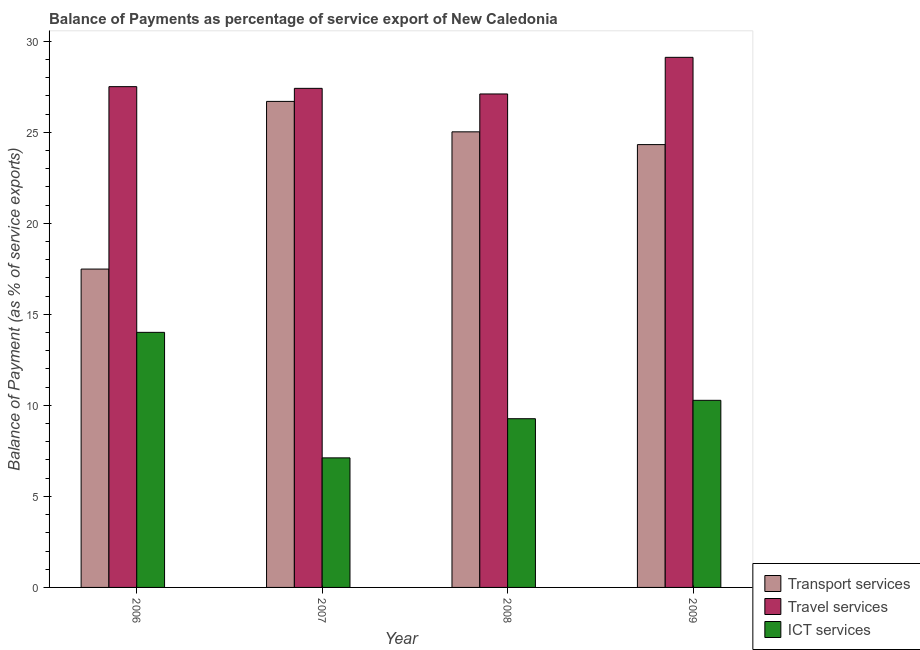What is the balance of payment of transport services in 2007?
Your answer should be compact. 26.7. Across all years, what is the maximum balance of payment of travel services?
Ensure brevity in your answer.  29.12. Across all years, what is the minimum balance of payment of ict services?
Provide a short and direct response. 7.12. In which year was the balance of payment of travel services maximum?
Keep it short and to the point. 2009. In which year was the balance of payment of travel services minimum?
Your answer should be very brief. 2008. What is the total balance of payment of transport services in the graph?
Keep it short and to the point. 93.54. What is the difference between the balance of payment of travel services in 2008 and that in 2009?
Provide a short and direct response. -2.01. What is the difference between the balance of payment of travel services in 2007 and the balance of payment of transport services in 2006?
Offer a terse response. -0.09. What is the average balance of payment of ict services per year?
Offer a very short reply. 10.17. What is the ratio of the balance of payment of ict services in 2006 to that in 2008?
Provide a short and direct response. 1.51. Is the difference between the balance of payment of travel services in 2006 and 2007 greater than the difference between the balance of payment of transport services in 2006 and 2007?
Your answer should be very brief. No. What is the difference between the highest and the second highest balance of payment of travel services?
Offer a very short reply. 1.61. What is the difference between the highest and the lowest balance of payment of travel services?
Give a very brief answer. 2.01. In how many years, is the balance of payment of ict services greater than the average balance of payment of ict services taken over all years?
Offer a very short reply. 2. What does the 3rd bar from the left in 2009 represents?
Your answer should be very brief. ICT services. What does the 3rd bar from the right in 2008 represents?
Provide a succinct answer. Transport services. Is it the case that in every year, the sum of the balance of payment of transport services and balance of payment of travel services is greater than the balance of payment of ict services?
Make the answer very short. Yes. How many bars are there?
Provide a short and direct response. 12. Are all the bars in the graph horizontal?
Offer a very short reply. No. How many years are there in the graph?
Keep it short and to the point. 4. What is the difference between two consecutive major ticks on the Y-axis?
Your response must be concise. 5. Are the values on the major ticks of Y-axis written in scientific E-notation?
Provide a short and direct response. No. Does the graph contain grids?
Give a very brief answer. No. Where does the legend appear in the graph?
Provide a succinct answer. Bottom right. What is the title of the graph?
Offer a terse response. Balance of Payments as percentage of service export of New Caledonia. Does "Coal" appear as one of the legend labels in the graph?
Your answer should be very brief. No. What is the label or title of the Y-axis?
Provide a short and direct response. Balance of Payment (as % of service exports). What is the Balance of Payment (as % of service exports) of Transport services in 2006?
Your answer should be very brief. 17.49. What is the Balance of Payment (as % of service exports) in Travel services in 2006?
Your answer should be very brief. 27.51. What is the Balance of Payment (as % of service exports) of ICT services in 2006?
Ensure brevity in your answer.  14.01. What is the Balance of Payment (as % of service exports) in Transport services in 2007?
Keep it short and to the point. 26.7. What is the Balance of Payment (as % of service exports) in Travel services in 2007?
Give a very brief answer. 27.42. What is the Balance of Payment (as % of service exports) in ICT services in 2007?
Your answer should be very brief. 7.12. What is the Balance of Payment (as % of service exports) in Transport services in 2008?
Your answer should be very brief. 25.03. What is the Balance of Payment (as % of service exports) in Travel services in 2008?
Offer a very short reply. 27.11. What is the Balance of Payment (as % of service exports) of ICT services in 2008?
Your answer should be compact. 9.27. What is the Balance of Payment (as % of service exports) in Transport services in 2009?
Ensure brevity in your answer.  24.33. What is the Balance of Payment (as % of service exports) in Travel services in 2009?
Provide a succinct answer. 29.12. What is the Balance of Payment (as % of service exports) of ICT services in 2009?
Give a very brief answer. 10.28. Across all years, what is the maximum Balance of Payment (as % of service exports) of Transport services?
Ensure brevity in your answer.  26.7. Across all years, what is the maximum Balance of Payment (as % of service exports) in Travel services?
Offer a terse response. 29.12. Across all years, what is the maximum Balance of Payment (as % of service exports) of ICT services?
Give a very brief answer. 14.01. Across all years, what is the minimum Balance of Payment (as % of service exports) in Transport services?
Keep it short and to the point. 17.49. Across all years, what is the minimum Balance of Payment (as % of service exports) in Travel services?
Your answer should be compact. 27.11. Across all years, what is the minimum Balance of Payment (as % of service exports) in ICT services?
Your response must be concise. 7.12. What is the total Balance of Payment (as % of service exports) of Transport services in the graph?
Your answer should be very brief. 93.54. What is the total Balance of Payment (as % of service exports) of Travel services in the graph?
Your answer should be compact. 111.15. What is the total Balance of Payment (as % of service exports) in ICT services in the graph?
Provide a short and direct response. 40.67. What is the difference between the Balance of Payment (as % of service exports) of Transport services in 2006 and that in 2007?
Offer a terse response. -9.21. What is the difference between the Balance of Payment (as % of service exports) of Travel services in 2006 and that in 2007?
Give a very brief answer. 0.09. What is the difference between the Balance of Payment (as % of service exports) in ICT services in 2006 and that in 2007?
Provide a succinct answer. 6.89. What is the difference between the Balance of Payment (as % of service exports) in Transport services in 2006 and that in 2008?
Your answer should be compact. -7.54. What is the difference between the Balance of Payment (as % of service exports) of Travel services in 2006 and that in 2008?
Your answer should be compact. 0.4. What is the difference between the Balance of Payment (as % of service exports) in ICT services in 2006 and that in 2008?
Provide a short and direct response. 4.74. What is the difference between the Balance of Payment (as % of service exports) of Transport services in 2006 and that in 2009?
Your answer should be very brief. -6.84. What is the difference between the Balance of Payment (as % of service exports) in Travel services in 2006 and that in 2009?
Make the answer very short. -1.61. What is the difference between the Balance of Payment (as % of service exports) of ICT services in 2006 and that in 2009?
Provide a succinct answer. 3.73. What is the difference between the Balance of Payment (as % of service exports) of Transport services in 2007 and that in 2008?
Ensure brevity in your answer.  1.67. What is the difference between the Balance of Payment (as % of service exports) in Travel services in 2007 and that in 2008?
Provide a short and direct response. 0.31. What is the difference between the Balance of Payment (as % of service exports) in ICT services in 2007 and that in 2008?
Make the answer very short. -2.15. What is the difference between the Balance of Payment (as % of service exports) of Transport services in 2007 and that in 2009?
Make the answer very short. 2.37. What is the difference between the Balance of Payment (as % of service exports) in Travel services in 2007 and that in 2009?
Provide a short and direct response. -1.7. What is the difference between the Balance of Payment (as % of service exports) of ICT services in 2007 and that in 2009?
Offer a terse response. -3.16. What is the difference between the Balance of Payment (as % of service exports) in Transport services in 2008 and that in 2009?
Provide a short and direct response. 0.7. What is the difference between the Balance of Payment (as % of service exports) in Travel services in 2008 and that in 2009?
Give a very brief answer. -2.01. What is the difference between the Balance of Payment (as % of service exports) in ICT services in 2008 and that in 2009?
Make the answer very short. -1.01. What is the difference between the Balance of Payment (as % of service exports) in Transport services in 2006 and the Balance of Payment (as % of service exports) in Travel services in 2007?
Your answer should be compact. -9.93. What is the difference between the Balance of Payment (as % of service exports) in Transport services in 2006 and the Balance of Payment (as % of service exports) in ICT services in 2007?
Keep it short and to the point. 10.37. What is the difference between the Balance of Payment (as % of service exports) in Travel services in 2006 and the Balance of Payment (as % of service exports) in ICT services in 2007?
Offer a very short reply. 20.39. What is the difference between the Balance of Payment (as % of service exports) in Transport services in 2006 and the Balance of Payment (as % of service exports) in Travel services in 2008?
Ensure brevity in your answer.  -9.62. What is the difference between the Balance of Payment (as % of service exports) in Transport services in 2006 and the Balance of Payment (as % of service exports) in ICT services in 2008?
Offer a terse response. 8.22. What is the difference between the Balance of Payment (as % of service exports) in Travel services in 2006 and the Balance of Payment (as % of service exports) in ICT services in 2008?
Your answer should be very brief. 18.24. What is the difference between the Balance of Payment (as % of service exports) of Transport services in 2006 and the Balance of Payment (as % of service exports) of Travel services in 2009?
Your response must be concise. -11.63. What is the difference between the Balance of Payment (as % of service exports) in Transport services in 2006 and the Balance of Payment (as % of service exports) in ICT services in 2009?
Your answer should be very brief. 7.21. What is the difference between the Balance of Payment (as % of service exports) of Travel services in 2006 and the Balance of Payment (as % of service exports) of ICT services in 2009?
Your answer should be compact. 17.23. What is the difference between the Balance of Payment (as % of service exports) of Transport services in 2007 and the Balance of Payment (as % of service exports) of Travel services in 2008?
Ensure brevity in your answer.  -0.41. What is the difference between the Balance of Payment (as % of service exports) of Transport services in 2007 and the Balance of Payment (as % of service exports) of ICT services in 2008?
Give a very brief answer. 17.43. What is the difference between the Balance of Payment (as % of service exports) in Travel services in 2007 and the Balance of Payment (as % of service exports) in ICT services in 2008?
Your answer should be compact. 18.15. What is the difference between the Balance of Payment (as % of service exports) of Transport services in 2007 and the Balance of Payment (as % of service exports) of Travel services in 2009?
Keep it short and to the point. -2.42. What is the difference between the Balance of Payment (as % of service exports) in Transport services in 2007 and the Balance of Payment (as % of service exports) in ICT services in 2009?
Offer a terse response. 16.42. What is the difference between the Balance of Payment (as % of service exports) in Travel services in 2007 and the Balance of Payment (as % of service exports) in ICT services in 2009?
Offer a terse response. 17.14. What is the difference between the Balance of Payment (as % of service exports) of Transport services in 2008 and the Balance of Payment (as % of service exports) of Travel services in 2009?
Make the answer very short. -4.09. What is the difference between the Balance of Payment (as % of service exports) of Transport services in 2008 and the Balance of Payment (as % of service exports) of ICT services in 2009?
Your answer should be very brief. 14.75. What is the difference between the Balance of Payment (as % of service exports) of Travel services in 2008 and the Balance of Payment (as % of service exports) of ICT services in 2009?
Provide a succinct answer. 16.83. What is the average Balance of Payment (as % of service exports) in Transport services per year?
Offer a very short reply. 23.38. What is the average Balance of Payment (as % of service exports) in Travel services per year?
Offer a terse response. 27.79. What is the average Balance of Payment (as % of service exports) of ICT services per year?
Your response must be concise. 10.17. In the year 2006, what is the difference between the Balance of Payment (as % of service exports) of Transport services and Balance of Payment (as % of service exports) of Travel services?
Your answer should be very brief. -10.02. In the year 2006, what is the difference between the Balance of Payment (as % of service exports) of Transport services and Balance of Payment (as % of service exports) of ICT services?
Keep it short and to the point. 3.48. In the year 2006, what is the difference between the Balance of Payment (as % of service exports) of Travel services and Balance of Payment (as % of service exports) of ICT services?
Your response must be concise. 13.5. In the year 2007, what is the difference between the Balance of Payment (as % of service exports) of Transport services and Balance of Payment (as % of service exports) of Travel services?
Your answer should be very brief. -0.72. In the year 2007, what is the difference between the Balance of Payment (as % of service exports) of Transport services and Balance of Payment (as % of service exports) of ICT services?
Ensure brevity in your answer.  19.58. In the year 2007, what is the difference between the Balance of Payment (as % of service exports) of Travel services and Balance of Payment (as % of service exports) of ICT services?
Offer a very short reply. 20.3. In the year 2008, what is the difference between the Balance of Payment (as % of service exports) of Transport services and Balance of Payment (as % of service exports) of Travel services?
Give a very brief answer. -2.08. In the year 2008, what is the difference between the Balance of Payment (as % of service exports) in Transport services and Balance of Payment (as % of service exports) in ICT services?
Your answer should be very brief. 15.76. In the year 2008, what is the difference between the Balance of Payment (as % of service exports) in Travel services and Balance of Payment (as % of service exports) in ICT services?
Ensure brevity in your answer.  17.84. In the year 2009, what is the difference between the Balance of Payment (as % of service exports) in Transport services and Balance of Payment (as % of service exports) in Travel services?
Provide a short and direct response. -4.79. In the year 2009, what is the difference between the Balance of Payment (as % of service exports) in Transport services and Balance of Payment (as % of service exports) in ICT services?
Ensure brevity in your answer.  14.05. In the year 2009, what is the difference between the Balance of Payment (as % of service exports) of Travel services and Balance of Payment (as % of service exports) of ICT services?
Make the answer very short. 18.84. What is the ratio of the Balance of Payment (as % of service exports) in Transport services in 2006 to that in 2007?
Your answer should be compact. 0.66. What is the ratio of the Balance of Payment (as % of service exports) of ICT services in 2006 to that in 2007?
Offer a very short reply. 1.97. What is the ratio of the Balance of Payment (as % of service exports) in Transport services in 2006 to that in 2008?
Offer a terse response. 0.7. What is the ratio of the Balance of Payment (as % of service exports) of Travel services in 2006 to that in 2008?
Make the answer very short. 1.01. What is the ratio of the Balance of Payment (as % of service exports) of ICT services in 2006 to that in 2008?
Keep it short and to the point. 1.51. What is the ratio of the Balance of Payment (as % of service exports) in Transport services in 2006 to that in 2009?
Give a very brief answer. 0.72. What is the ratio of the Balance of Payment (as % of service exports) of Travel services in 2006 to that in 2009?
Offer a very short reply. 0.94. What is the ratio of the Balance of Payment (as % of service exports) of ICT services in 2006 to that in 2009?
Offer a very short reply. 1.36. What is the ratio of the Balance of Payment (as % of service exports) of Transport services in 2007 to that in 2008?
Your answer should be very brief. 1.07. What is the ratio of the Balance of Payment (as % of service exports) in Travel services in 2007 to that in 2008?
Give a very brief answer. 1.01. What is the ratio of the Balance of Payment (as % of service exports) in ICT services in 2007 to that in 2008?
Ensure brevity in your answer.  0.77. What is the ratio of the Balance of Payment (as % of service exports) in Transport services in 2007 to that in 2009?
Provide a short and direct response. 1.1. What is the ratio of the Balance of Payment (as % of service exports) in Travel services in 2007 to that in 2009?
Provide a succinct answer. 0.94. What is the ratio of the Balance of Payment (as % of service exports) in ICT services in 2007 to that in 2009?
Provide a short and direct response. 0.69. What is the ratio of the Balance of Payment (as % of service exports) of Transport services in 2008 to that in 2009?
Offer a terse response. 1.03. What is the ratio of the Balance of Payment (as % of service exports) in Travel services in 2008 to that in 2009?
Ensure brevity in your answer.  0.93. What is the ratio of the Balance of Payment (as % of service exports) in ICT services in 2008 to that in 2009?
Your answer should be compact. 0.9. What is the difference between the highest and the second highest Balance of Payment (as % of service exports) of Transport services?
Ensure brevity in your answer.  1.67. What is the difference between the highest and the second highest Balance of Payment (as % of service exports) of Travel services?
Provide a succinct answer. 1.61. What is the difference between the highest and the second highest Balance of Payment (as % of service exports) in ICT services?
Offer a terse response. 3.73. What is the difference between the highest and the lowest Balance of Payment (as % of service exports) of Transport services?
Your response must be concise. 9.21. What is the difference between the highest and the lowest Balance of Payment (as % of service exports) in Travel services?
Ensure brevity in your answer.  2.01. What is the difference between the highest and the lowest Balance of Payment (as % of service exports) in ICT services?
Give a very brief answer. 6.89. 